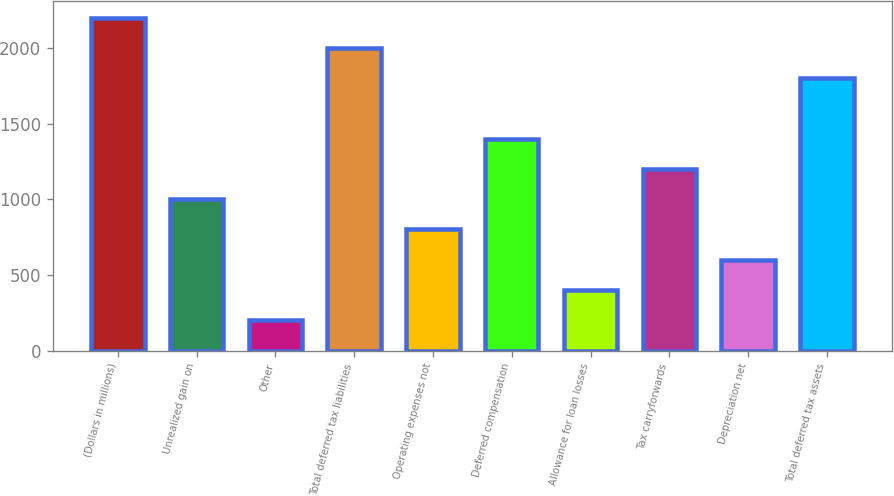<chart> <loc_0><loc_0><loc_500><loc_500><bar_chart><fcel>(Dollars in millions)<fcel>Unrealized gain on<fcel>Other<fcel>Total deferred tax liabilities<fcel>Operating expenses not<fcel>Deferred compensation<fcel>Allowance for loan losses<fcel>Tax carryforwards<fcel>Depreciation net<fcel>Total deferred tax assets<nl><fcel>2200.8<fcel>1002<fcel>202.8<fcel>2001<fcel>802.2<fcel>1401.6<fcel>402.6<fcel>1201.8<fcel>602.4<fcel>1801.2<nl></chart> 